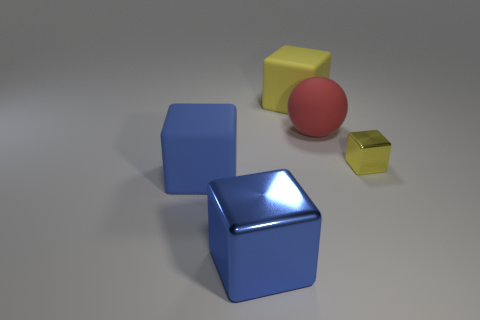There is another block that is the same color as the small metal cube; what is its material?
Offer a terse response. Rubber. What number of red objects are made of the same material as the red sphere?
Provide a succinct answer. 0. The big rubber thing that is on the right side of the blue shiny cube and to the left of the large matte sphere has what shape?
Provide a succinct answer. Cube. How many objects are either cubes that are to the left of the small yellow thing or metallic cubes to the left of the big yellow matte block?
Your answer should be very brief. 3. Are there the same number of objects that are in front of the big red object and red rubber things that are behind the small block?
Offer a terse response. No. There is a metallic object to the left of the big block on the right side of the large metallic cube; what is its shape?
Your answer should be very brief. Cube. Is there a big blue metallic thing that has the same shape as the big red rubber object?
Your answer should be compact. No. How many red spheres are there?
Your response must be concise. 1. Does the block that is behind the yellow shiny block have the same material as the red thing?
Offer a terse response. Yes. Is there a red metal object of the same size as the red rubber sphere?
Offer a very short reply. No. 